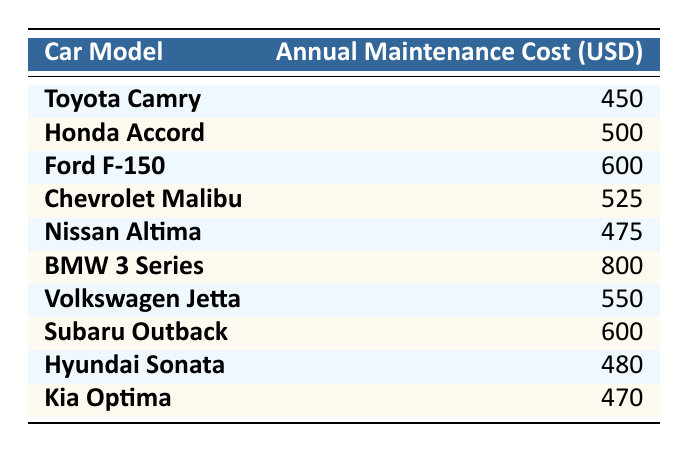What is the annual maintenance cost of the Toyota Camry? The table lists the annual maintenance cost of the Toyota Camry as 450 USD.
Answer: 450 Which car model has the highest annual maintenance cost? By reviewing the table, the BMW 3 Series is noted with the highest annual maintenance cost of 800 USD.
Answer: BMW 3 Series How much more does the Ford F-150 cost to maintain annually compared to the Kia Optima? The Ford F-150 has an annual maintenance cost of 600 USD, while the Kia Optima costs 470 USD. The difference is calculated as 600 - 470 = 130 USD.
Answer: 130 What is the average annual maintenance cost of all the listed car models? To find the average, sum all the annual costs: 450 + 500 + 600 + 525 + 475 + 800 + 550 + 600 + 480 + 470 = 5250. Then, divide this total by the number of models (10): 5250 / 10 = 525.
Answer: 525 Is the annual maintenance cost of the Nissan Altima greater than that of the Chevrolet Malibu? The Nissan Altima costs 475 USD, and the Chevrolet Malibu costs 525 USD. Since 475 is less than 525, the statement is false.
Answer: No What is the total annual maintenance cost for both the Subaru Outback and the Volkswagen Jetta? The Subaru Outback costs 600 USD and the Volkswagen Jetta costs 550 USD. By adding these amounts together, 600 + 550 = 1150 USD.
Answer: 1150 Does the Honda Accord have a lower maintenance cost than the Hyundai Sonata? The Honda Accord's maintenance cost is 500 USD, while the Hyundai Sonata's is 480 USD. Since 500 is greater than 480, the statement is false.
Answer: No Which two car models have annual maintenance costs that are the closest to each other? Comparing the differences in costs, the Hyundai Sonata (480 USD) and the Kia Optima (470 USD) have the smallest difference of 10 USD.
Answer: Hyundai Sonata and Kia Optima What is the difference in maintenance cost between the cheapest and the most expensive car model? The cheapest car model is the Toyota Camry at 450 USD, and the most expensive is the BMW 3 Series at 800 USD. The difference is calculated as 800 - 450 = 350 USD.
Answer: 350 